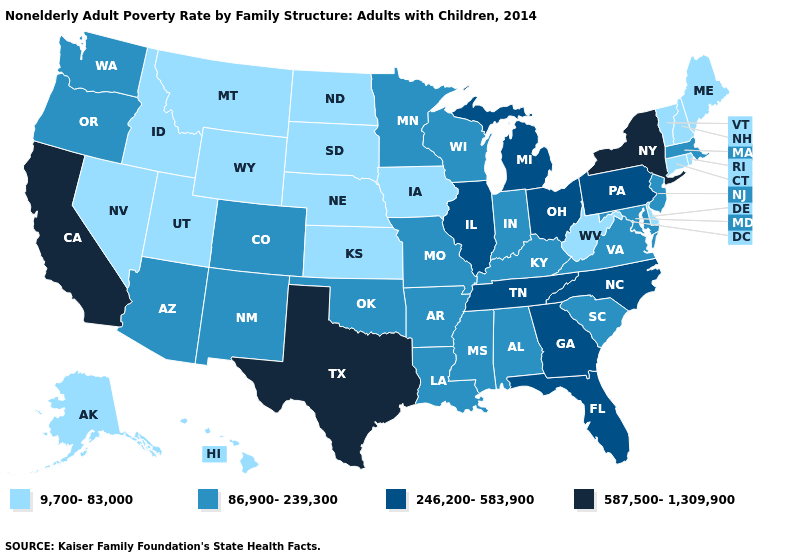Does the first symbol in the legend represent the smallest category?
Quick response, please. Yes. Does the map have missing data?
Be succinct. No. Which states hav the highest value in the MidWest?
Quick response, please. Illinois, Michigan, Ohio. Does the map have missing data?
Be succinct. No. What is the highest value in the USA?
Quick response, please. 587,500-1,309,900. What is the value of Massachusetts?
Concise answer only. 86,900-239,300. Among the states that border Ohio , does West Virginia have the lowest value?
Write a very short answer. Yes. Among the states that border North Carolina , does South Carolina have the lowest value?
Concise answer only. Yes. What is the value of South Dakota?
Write a very short answer. 9,700-83,000. Which states have the highest value in the USA?
Quick response, please. California, New York, Texas. What is the value of Georgia?
Short answer required. 246,200-583,900. What is the value of Missouri?
Concise answer only. 86,900-239,300. What is the lowest value in the Northeast?
Write a very short answer. 9,700-83,000. What is the highest value in states that border New York?
Short answer required. 246,200-583,900. 